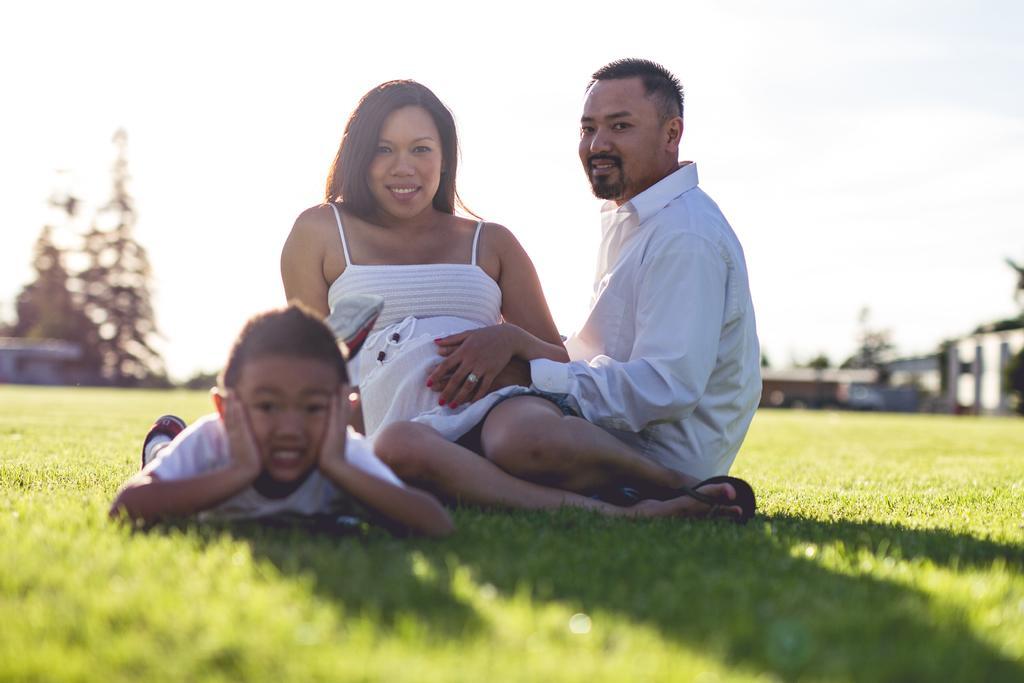Can you describe this image briefly? In this image I can see 2 people sitting on the grass, wearing white dress. A child is lying on the left. There are trees and buildings at the back. 